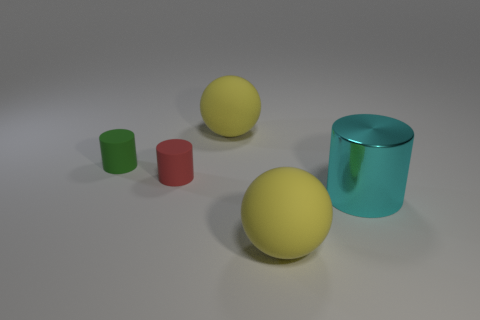How big is the yellow thing on the left side of the yellow object that is in front of the large cyan metal cylinder?
Provide a succinct answer. Large. Are there the same number of cyan metallic cylinders in front of the cyan metallic cylinder and large shiny objects left of the red matte cylinder?
Your response must be concise. Yes. Are there any other things that have the same size as the cyan thing?
Give a very brief answer. Yes. The tiny cylinder that is the same material as the red object is what color?
Give a very brief answer. Green. Does the green object have the same material as the large thing that is behind the cyan object?
Your answer should be very brief. Yes. The cylinder that is both behind the large cyan object and in front of the green matte cylinder is what color?
Your response must be concise. Red. What number of cylinders are tiny green objects or purple rubber objects?
Your response must be concise. 1. Is the shape of the cyan object the same as the small rubber object that is in front of the tiny green rubber thing?
Your response must be concise. Yes. What size is the thing that is in front of the small red cylinder and to the left of the cyan shiny cylinder?
Provide a short and direct response. Large. What is the shape of the tiny red matte thing?
Ensure brevity in your answer.  Cylinder. 